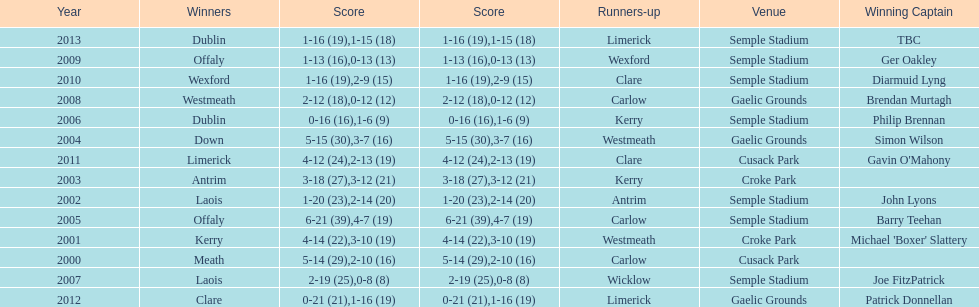Can you give me this table as a dict? {'header': ['Year', 'Winners', 'Score', 'Score', 'Runners-up', 'Venue', 'Winning Captain'], 'rows': [['2013', 'Dublin', '1-16 (19)', '1-15 (18)', 'Limerick', 'Semple Stadium', 'TBC'], ['2009', 'Offaly', '1-13 (16)', '0-13 (13)', 'Wexford', 'Semple Stadium', 'Ger Oakley'], ['2010', 'Wexford', '1-16 (19)', '2-9 (15)', 'Clare', 'Semple Stadium', 'Diarmuid Lyng'], ['2008', 'Westmeath', '2-12 (18)', '0-12 (12)', 'Carlow', 'Gaelic Grounds', 'Brendan Murtagh'], ['2006', 'Dublin', '0-16 (16)', '1-6 (9)', 'Kerry', 'Semple Stadium', 'Philip Brennan'], ['2004', 'Down', '5-15 (30)', '3-7 (16)', 'Westmeath', 'Gaelic Grounds', 'Simon Wilson'], ['2011', 'Limerick', '4-12 (24)', '2-13 (19)', 'Clare', 'Cusack Park', "Gavin O'Mahony"], ['2003', 'Antrim', '3-18 (27)', '3-12 (21)', 'Kerry', 'Croke Park', ''], ['2002', 'Laois', '1-20 (23)', '2-14 (20)', 'Antrim', 'Semple Stadium', 'John Lyons'], ['2005', 'Offaly', '6-21 (39)', '4-7 (19)', 'Carlow', 'Semple Stadium', 'Barry Teehan'], ['2001', 'Kerry', '4-14 (22)', '3-10 (19)', 'Westmeath', 'Croke Park', "Michael 'Boxer' Slattery"], ['2000', 'Meath', '5-14 (29)', '2-10 (16)', 'Carlow', 'Cusack Park', ''], ['2007', 'Laois', '2-19 (25)', '0-8 (8)', 'Wicklow', 'Semple Stadium', 'Joe FitzPatrick'], ['2012', 'Clare', '0-21 (21)', '1-16 (19)', 'Limerick', 'Gaelic Grounds', 'Patrick Donnellan']]} Who was the victorious captain during the previous competition at the gaelic grounds venue? Patrick Donnellan. 